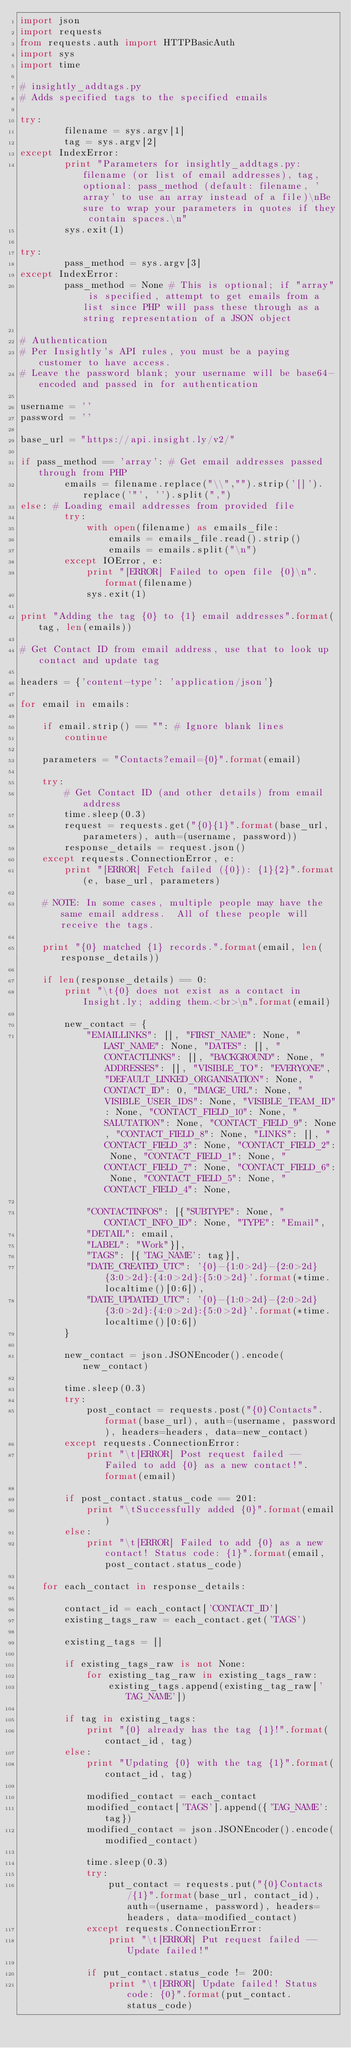Convert code to text. <code><loc_0><loc_0><loc_500><loc_500><_Python_>import json
import requests
from requests.auth import HTTPBasicAuth
import sys
import time

# insightly_addtags.py
# Adds specified tags to the specified emails

try:
        filename = sys.argv[1]
        tag = sys.argv[2]
except IndexError:
        print "Parameters for insightly_addtags.py: filename (or list of email addresses), tag, optional: pass_method (default: filename, 'array' to use an array instead of a file)\nBe sure to wrap your parameters in quotes if they contain spaces.\n"
        sys.exit(1)

try:
        pass_method = sys.argv[3]
except IndexError:
        pass_method = None # This is optional; if "array" is specified, attempt to get emails from a list since PHP will pass these through as a string representation of a JSON object

# Authentication
# Per Insightly's API rules, you must be a paying customer to have access.
# Leave the password blank; your username will be base64-encoded and passed in for authentication

username = ''
password = ''

base_url = "https://api.insight.ly/v2/"

if pass_method == 'array': # Get email addresses passed through from PHP
        emails = filename.replace("\\","").strip('[]').replace('"', '').split(",")
else: # Loading email addresses from provided file
        try:
            with open(filename) as emails_file:
                emails = emails_file.read().strip()
                emails = emails.split("\n")
        except IOError, e:
            print "[ERROR] Failed to open file {0}\n".format(filename)
            sys.exit(1)

print "Adding the tag {0} to {1} email addresses".format(tag, len(emails))

# Get Contact ID from email address, use that to look up contact and update tag

headers = {'content-type': 'application/json'}

for email in emails:

    if email.strip() == "": # Ignore blank lines
        continue

    parameters = "Contacts?email={0}".format(email)

    try:
        # Get Contact ID (and other details) from email address
        time.sleep(0.3)
        request = requests.get("{0}{1}".format(base_url, parameters), auth=(username, password))
        response_details = request.json()
    except requests.ConnectionError, e:
        print "[ERROR] Fetch failed ({0}): {1}{2}".format(e, base_url, parameters)

    # NOTE: In some cases, multiple people may have the same email address.  All of these people will receive the tags.

    print "{0} matched {1} records.".format(email, len(response_details))

    if len(response_details) == 0:
        print "\t{0} does not exist as a contact in Insight.ly; adding them.<br>\n".format(email)

        new_contact = {  
            "EMAILLINKS": [], "FIRST_NAME": None, "LAST_NAME": None, "DATES": [], "CONTACTLINKS": [], "BACKGROUND": None, "ADDRESSES": [], "VISIBLE_TO": "EVERYONE", "DEFAULT_LINKED_ORGANISATION": None, "CONTACT_ID": 0, "IMAGE_URL": None, "VISIBLE_USER_IDS": None, "VISIBLE_TEAM_ID": None, "CONTACT_FIELD_10": None, "SALUTATION": None, "CONTACT_FIELD_9": None, "CONTACT_FIELD_8": None, "LINKS": [], "CONTACT_FIELD_3": None, "CONTACT_FIELD_2": None, "CONTACT_FIELD_1": None, "CONTACT_FIELD_7": None, "CONTACT_FIELD_6": None, "CONTACT_FIELD_5": None, "CONTACT_FIELD_4": None, 

            "CONTACTINFOS": [{"SUBTYPE": None, "CONTACT_INFO_ID": None, "TYPE": "Email", 
            "DETAIL": email, 
            "LABEL": "Work"}],
            "TAGS": [{'TAG_NAME': tag}],
            "DATE_CREATED_UTC": '{0}-{1:0>2d}-{2:0>2d} {3:0>2d}:{4:0>2d}:{5:0>2d}'.format(*time.localtime()[0:6]),
            "DATE_UPDATED_UTC": '{0}-{1:0>2d}-{2:0>2d} {3:0>2d}:{4:0>2d}:{5:0>2d}'.format(*time.localtime()[0:6])
        }

        new_contact = json.JSONEncoder().encode(new_contact)

        time.sleep(0.3)
        try:
            post_contact = requests.post("{0}Contacts".format(base_url), auth=(username, password), headers=headers, data=new_contact)
        except requests.ConnectionError:
            print "\t[ERROR] Post request failed -- Failed to add {0} as a new contact!".format(email)   

        if post_contact.status_code == 201:
            print "\tSuccessfully added {0}".format(email)
        else:
            print "\t[ERROR] Failed to add {0} as a new contact! Status code: {1}".format(email, post_contact.status_code)

    for each_contact in response_details:

        contact_id = each_contact['CONTACT_ID']
        existing_tags_raw = each_contact.get('TAGS')

        existing_tags = []

        if existing_tags_raw is not None:
            for existing_tag_raw in existing_tags_raw:
                existing_tags.append(existing_tag_raw['TAG_NAME'])

        if tag in existing_tags:
            print "{0} already has the tag {1}!".format(contact_id, tag)
        else:
            print "Updating {0} with the tag {1}".format(contact_id, tag)

            modified_contact = each_contact
            modified_contact['TAGS'].append({'TAG_NAME': tag})
            modified_contact = json.JSONEncoder().encode(modified_contact)

            time.sleep(0.3)
            try:
                put_contact = requests.put("{0}Contacts/{1}".format(base_url, contact_id), auth=(username, password), headers=headers, data=modified_contact)
            except requests.ConnectionError:
                print "\t[ERROR] Put request failed -- Update failed!"                

            if put_contact.status_code != 200:
                print "\t[ERROR] Update failed! Status code: {0}".format(put_contact.status_code)
</code> 